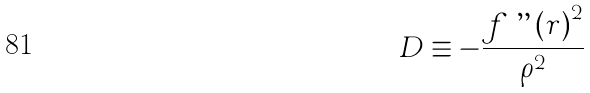Convert formula to latex. <formula><loc_0><loc_0><loc_500><loc_500>D \equiv - \frac { f \ " \left ( r \right ) ^ { 2 } } { \rho ^ { 2 } }</formula> 